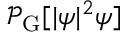<formula> <loc_0><loc_0><loc_500><loc_500>\mathcal { P } _ { G } [ | \psi | ^ { 2 } \psi ]</formula> 